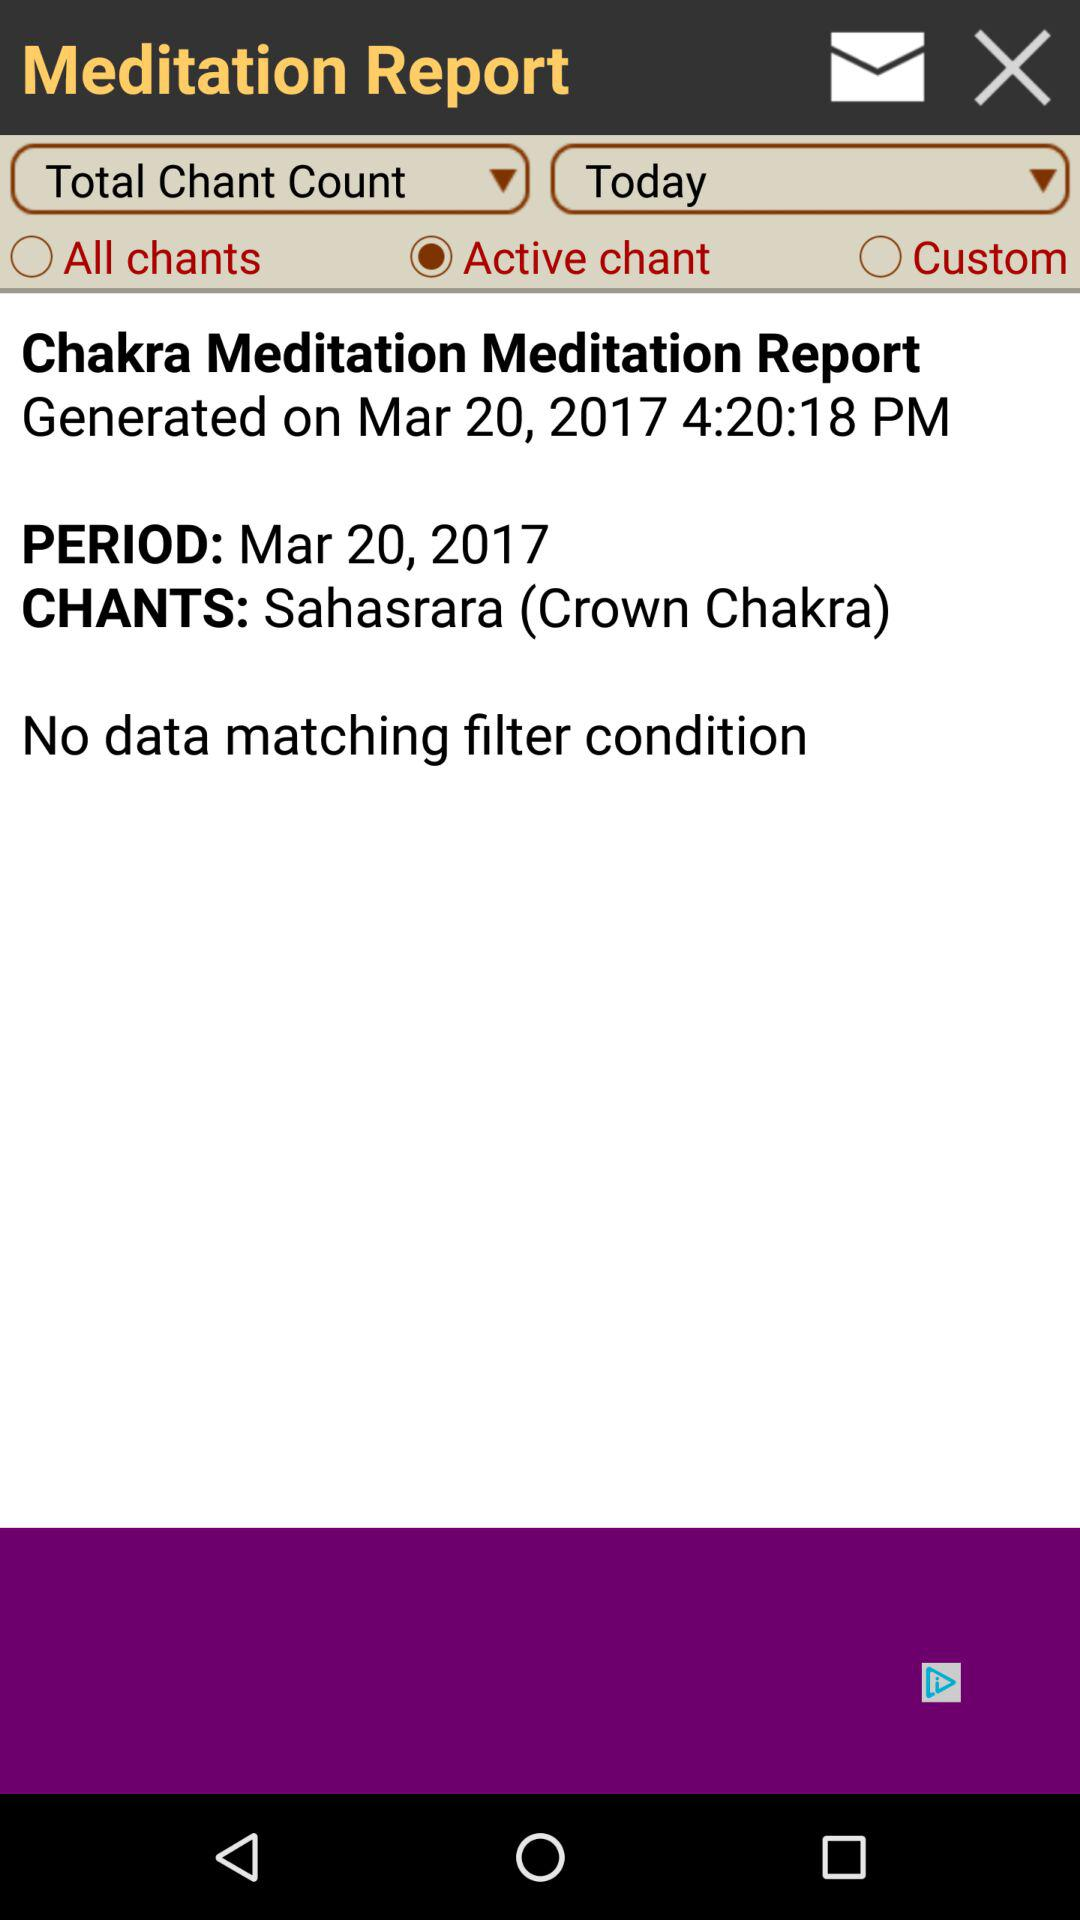What is the period? The period is March 20, 2017. 